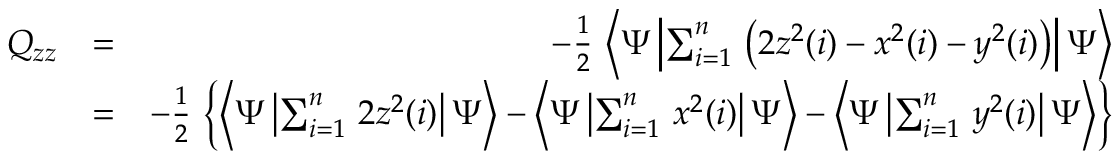Convert formula to latex. <formula><loc_0><loc_0><loc_500><loc_500>\begin{array} { r l r } { Q _ { z z } } & { = } & { - \frac { 1 } { 2 } \, \left < \Psi \left | \sum _ { i = 1 } ^ { n } \, \left ( 2 z ^ { 2 } ( i ) - x ^ { 2 } ( i ) - y ^ { 2 } ( i ) \right ) \right | \Psi \right > } \\ & { = } & { - \frac { 1 } { 2 } \, \left \{ \left < \Psi \left | \sum _ { i = 1 } ^ { n } \, 2 z ^ { 2 } ( i ) \right | \Psi \right > - \left < \Psi \left | \sum _ { i = 1 } ^ { n } \, x ^ { 2 } ( i ) \right | \Psi \right > - \left < \Psi \left | \sum _ { i = 1 } ^ { n } \, y ^ { 2 } ( i ) \right | \Psi \right > \right \} } \end{array}</formula> 